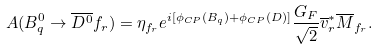Convert formula to latex. <formula><loc_0><loc_0><loc_500><loc_500>A ( B _ { q } ^ { 0 } \to \overline { { { D ^ { 0 } } } } f _ { r } ) = \eta _ { f _ { r } } e ^ { i [ \phi _ { C P } ( B _ { q } ) + \phi _ { C P } ( D ) ] } \frac { G _ { F } } { \sqrt { 2 } } \overline { v } _ { r } ^ { \ast } \overline { M } _ { f _ { r } } .</formula> 